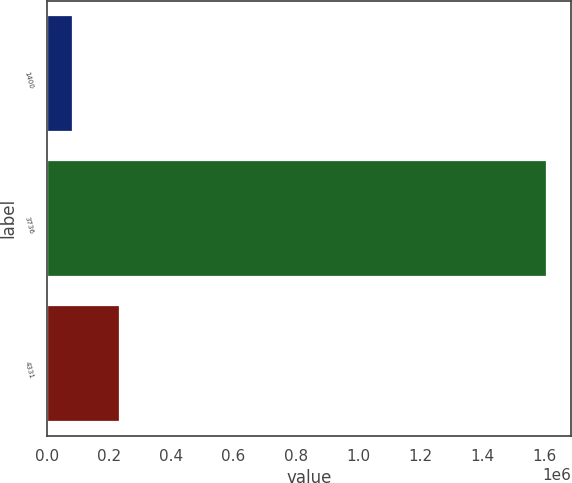Convert chart to OTSL. <chart><loc_0><loc_0><loc_500><loc_500><bar_chart><fcel>1400<fcel>3736<fcel>4331<nl><fcel>80636<fcel>1.60378e+06<fcel>232950<nl></chart> 